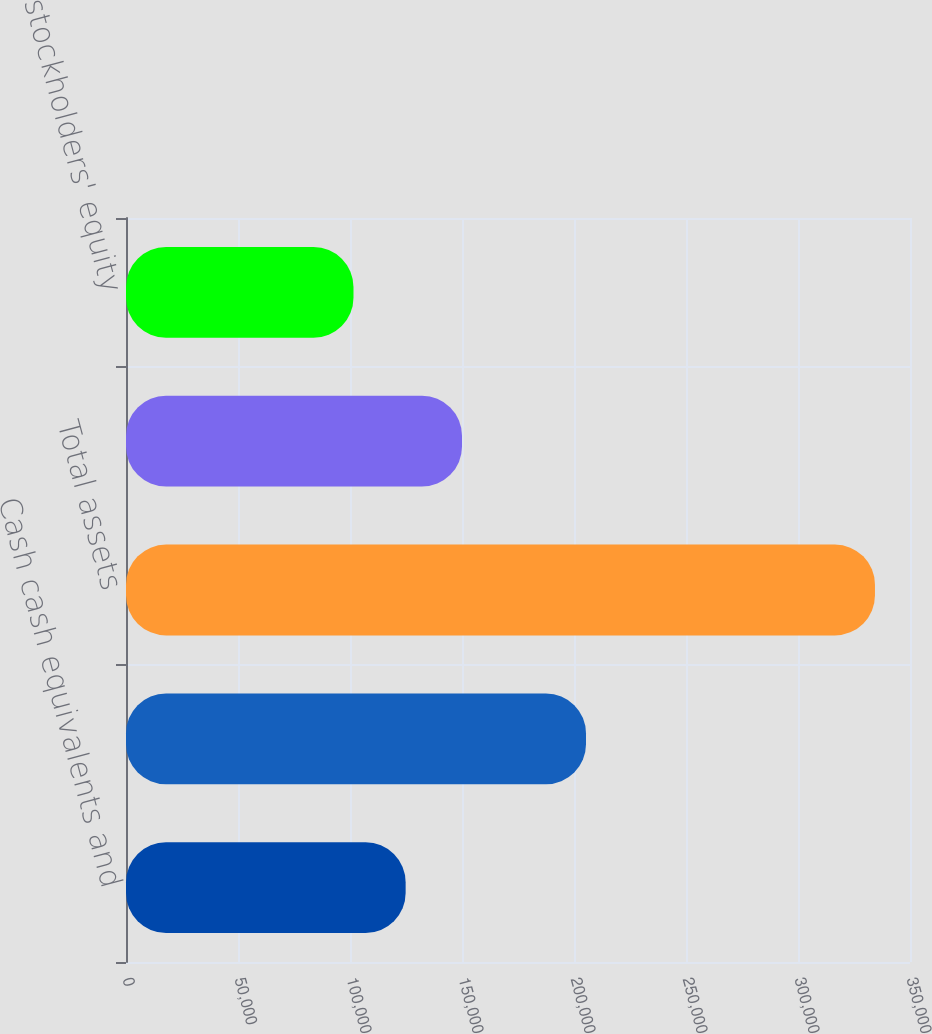Convert chart to OTSL. <chart><loc_0><loc_0><loc_500><loc_500><bar_chart><fcel>Cash cash equivalents and<fcel>Total current assets<fcel>Total assets<fcel>Convertible subordinated notes<fcel>Total stockholders' equity<nl><fcel>124836<fcel>205354<fcel>334357<fcel>150000<fcel>101556<nl></chart> 